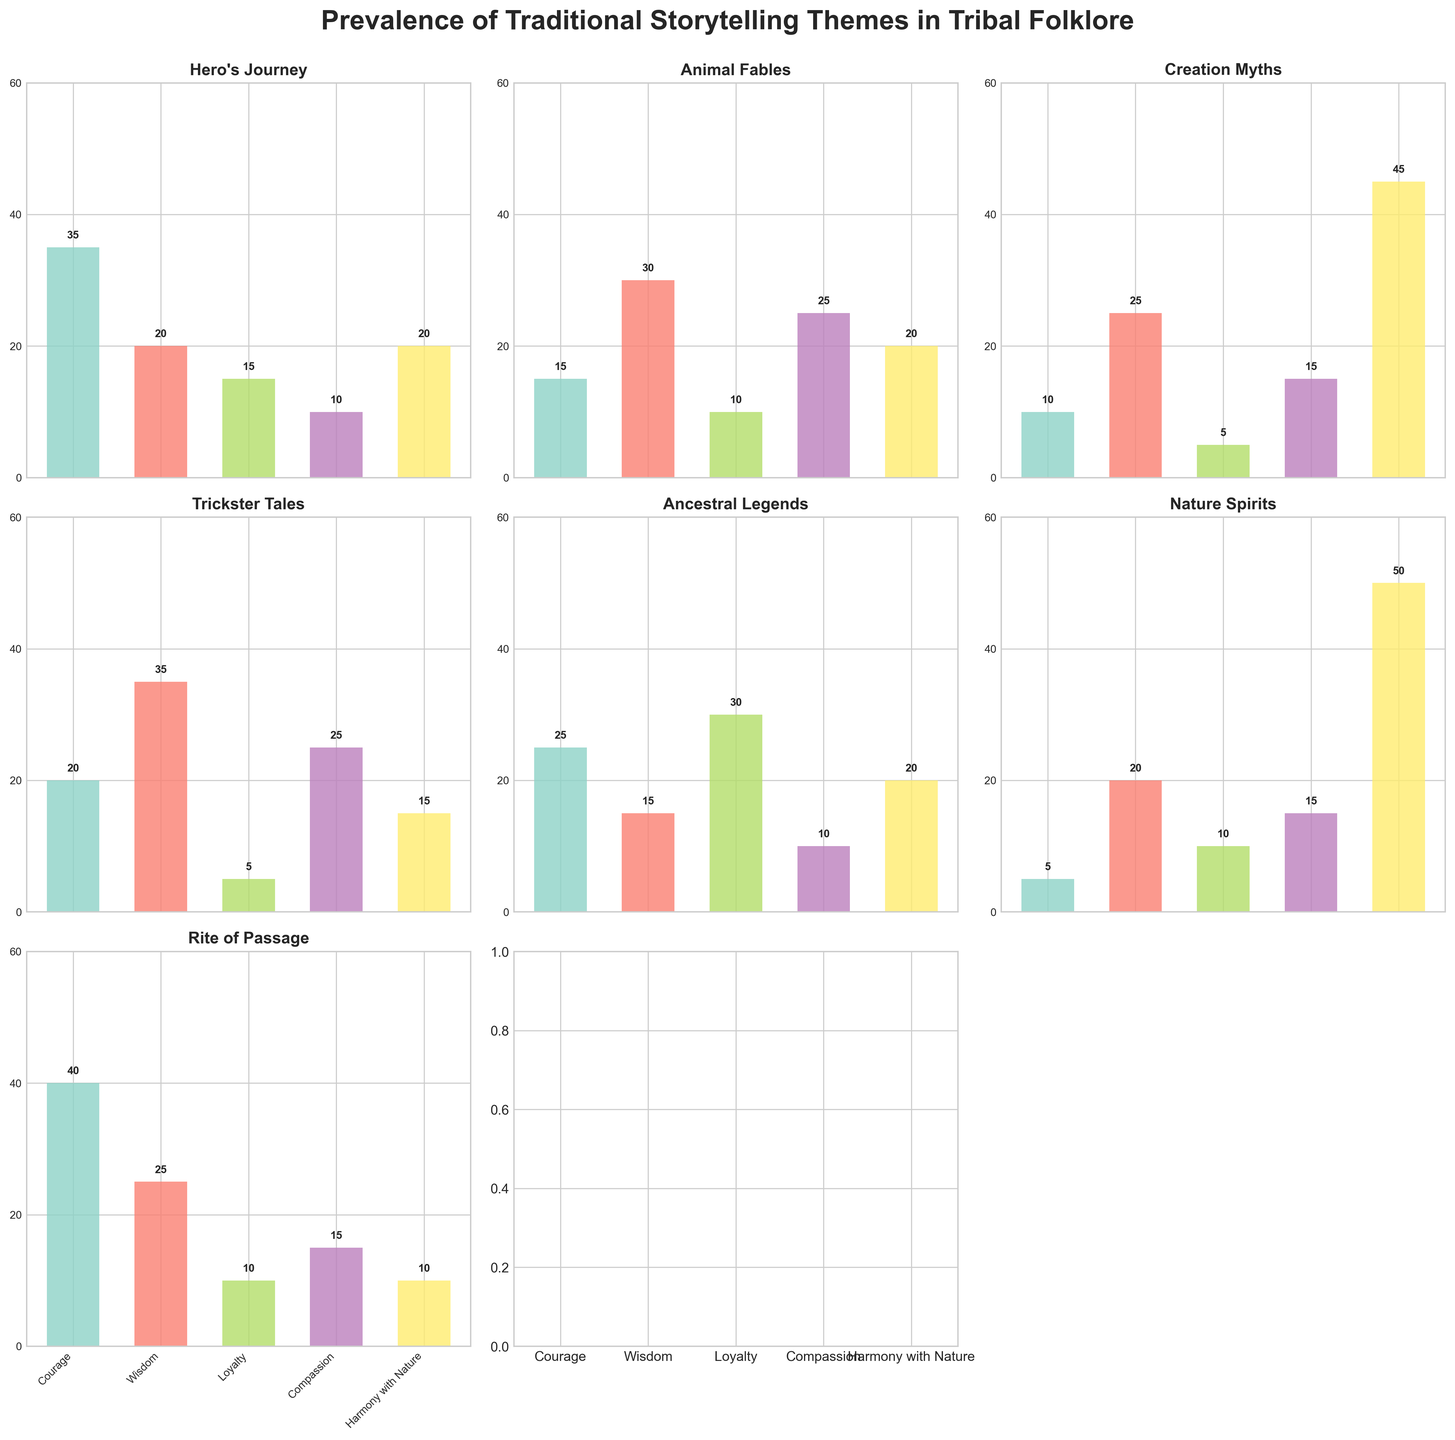What's the title of the figure? The title of the figure is usually placed at the top of the chart and provides an overview of what the figure is about. By reading the top of the figure, we can see the text "Prevalence of Traditional Storytelling Themes in Tribal Folklore".
Answer: Prevalence of Traditional Storytelling Themes in Tribal Folklore Which theme is most associated with Compassion? Look for the bar chart labeled "Compassion" in each subplot and identify the highest bar. In the subplot for "Animal Fables", we see a bar reaching up to 25, which is the highest value for Compassion among all themes.
Answer: Animal Fables What is the total prevalence of Courage in "Hero's Journey" and "Rite of Passage"? The prevalence values for Courage in "Hero's Journey" and "Rite of Passage" are 35 and 40, respectively. Their sum is calculated by adding these two numbers: 35 + 40 = 75.
Answer: 75 How many moral lessons are considered in the figure? The moral lessons are labeled on the x-axis of the bottom row subplots. By counting these labels, we observe the lessons are Courage, Wisdom, Loyalty, Compassion, and Harmony with Nature. This gives us a total of 5 moral lessons.
Answer: 5 Which theme has the lowest prevalence of Loyalty? Examine the bars corresponding to Loyalty (typically the third bar in each subplot) and identify the theme with the shortest bar. "Trickster Tales" and "Creation Myths" both have the lowest value of 5 for Loyalty.
Answer: Trickster Tales and Creation Myths What's the difference in the prevalence of Wisdom between "Creation Myths" and "Hero's Journey"? The subplot for "Creation Myths" shows a Wisdom value of 25, while "Hero's Journey" shows a value of 20. The difference is found by subtracting the lower value from the higher one: 25 - 20 = 5.
Answer: 5 Which theme emphasizes Harmony with Nature the most? Look for the bar labeled Harmony with Nature in each subplot to find the highest bar. The "Nature Spirits" subplot shows a bar reaching up to 50, which is the highest value for Harmony with Nature among all themes.
Answer: Nature Spirits Compare the prevalence of Compassion in "Animal Fables" and "Trickster Tales". Which is higher, and by how much? In the subplot for "Animal Fables", Compassion has a value of 25, and in "Trickster Tales", the value is also 25. Hence, there is no difference as both values are equal.
Answer: Both are equal 